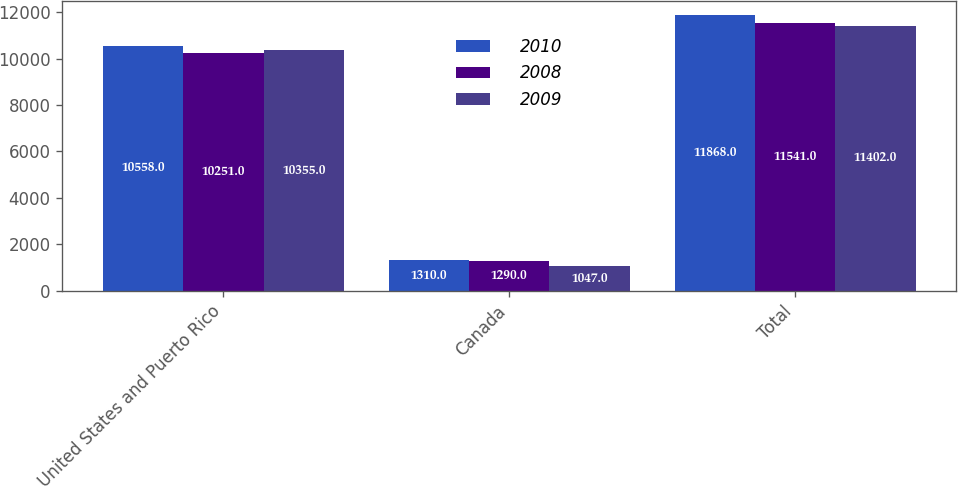Convert chart. <chart><loc_0><loc_0><loc_500><loc_500><stacked_bar_chart><ecel><fcel>United States and Puerto Rico<fcel>Canada<fcel>Total<nl><fcel>2010<fcel>10558<fcel>1310<fcel>11868<nl><fcel>2008<fcel>10251<fcel>1290<fcel>11541<nl><fcel>2009<fcel>10355<fcel>1047<fcel>11402<nl></chart> 